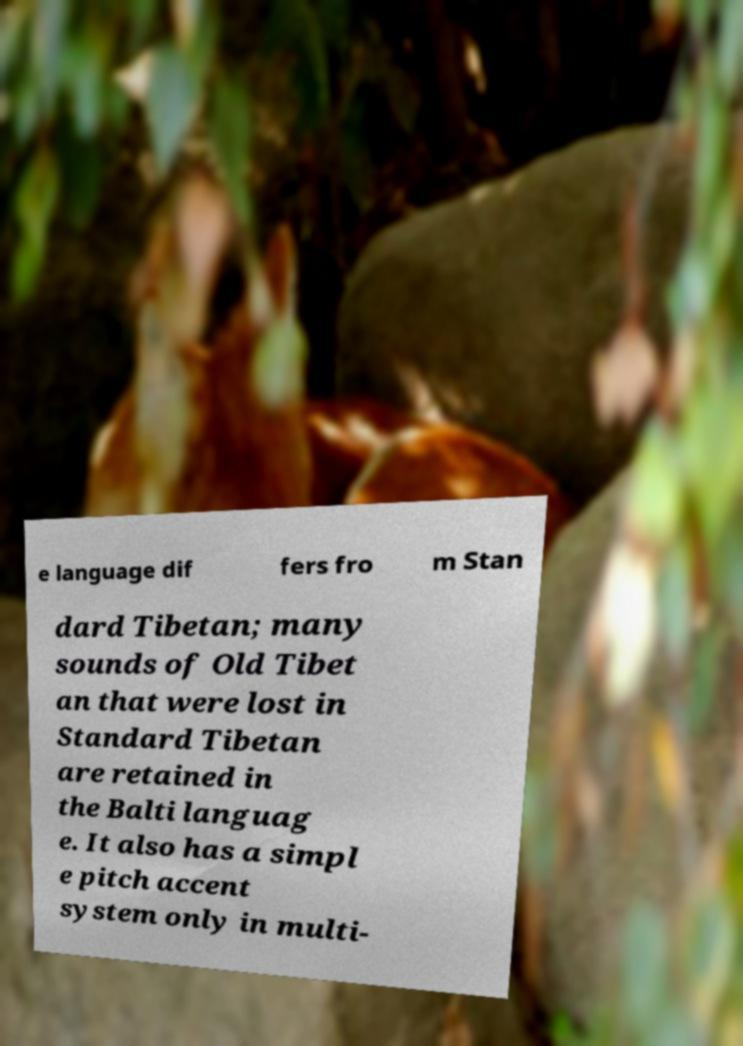There's text embedded in this image that I need extracted. Can you transcribe it verbatim? e language dif fers fro m Stan dard Tibetan; many sounds of Old Tibet an that were lost in Standard Tibetan are retained in the Balti languag e. It also has a simpl e pitch accent system only in multi- 